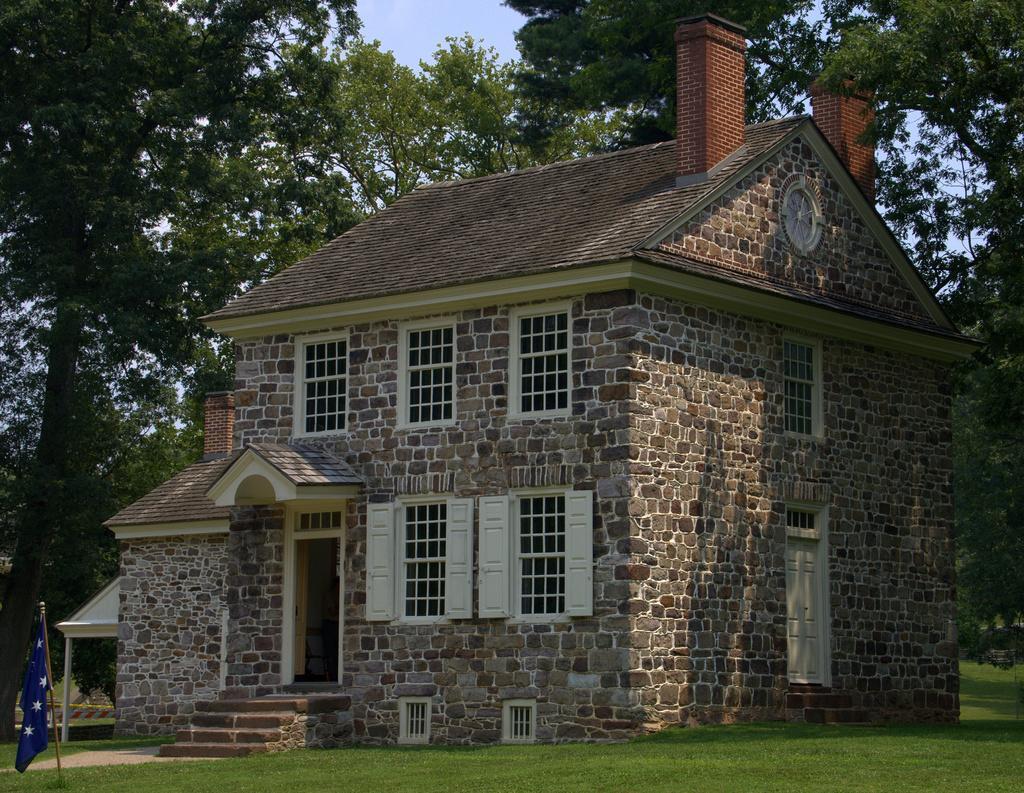Could you give a brief overview of what you see in this image? In the center of the picture there is a house, made with stone wall and there are windows and doors. In the foreground there is grass. On the left there is a flag. In the background there are trees and sky. 